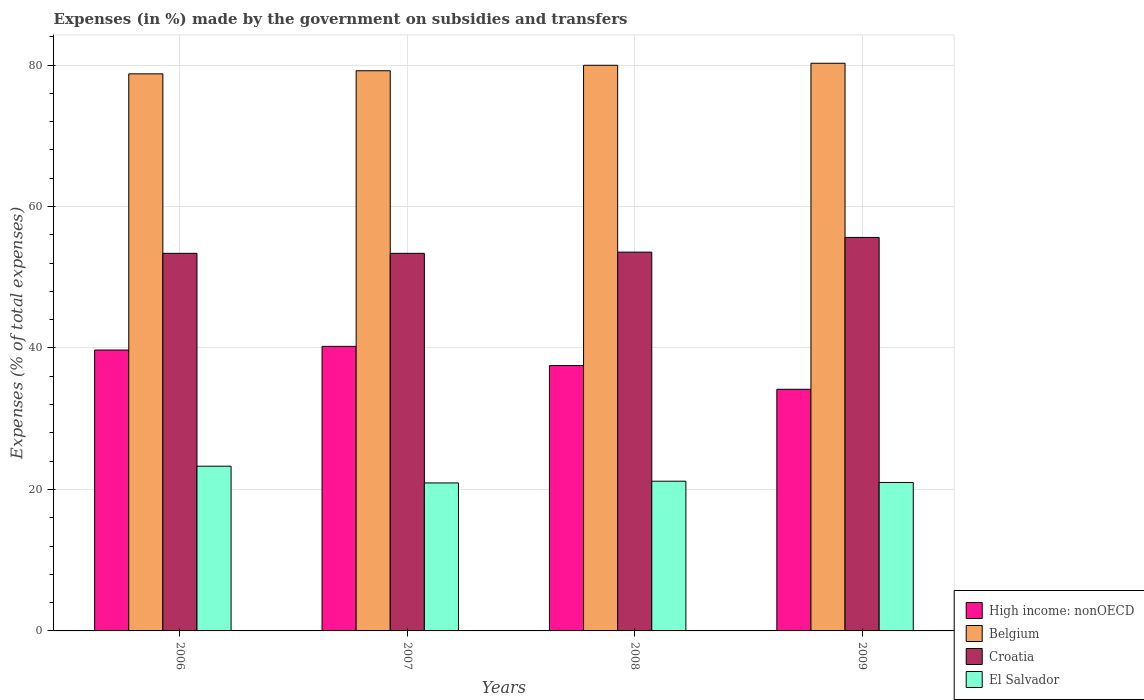How many different coloured bars are there?
Keep it short and to the point. 4. How many groups of bars are there?
Provide a short and direct response. 4. Are the number of bars per tick equal to the number of legend labels?
Offer a very short reply. Yes. How many bars are there on the 2nd tick from the left?
Your answer should be very brief. 4. What is the percentage of expenses made by the government on subsidies and transfers in El Salvador in 2008?
Your answer should be compact. 21.17. Across all years, what is the maximum percentage of expenses made by the government on subsidies and transfers in El Salvador?
Your answer should be very brief. 23.29. Across all years, what is the minimum percentage of expenses made by the government on subsidies and transfers in High income: nonOECD?
Ensure brevity in your answer.  34.16. In which year was the percentage of expenses made by the government on subsidies and transfers in High income: nonOECD maximum?
Provide a short and direct response. 2007. In which year was the percentage of expenses made by the government on subsidies and transfers in El Salvador minimum?
Make the answer very short. 2007. What is the total percentage of expenses made by the government on subsidies and transfers in Croatia in the graph?
Ensure brevity in your answer.  215.95. What is the difference between the percentage of expenses made by the government on subsidies and transfers in High income: nonOECD in 2006 and that in 2009?
Ensure brevity in your answer.  5.55. What is the difference between the percentage of expenses made by the government on subsidies and transfers in El Salvador in 2007 and the percentage of expenses made by the government on subsidies and transfers in Belgium in 2009?
Provide a short and direct response. -59.33. What is the average percentage of expenses made by the government on subsidies and transfers in Croatia per year?
Keep it short and to the point. 53.99. In the year 2008, what is the difference between the percentage of expenses made by the government on subsidies and transfers in High income: nonOECD and percentage of expenses made by the government on subsidies and transfers in El Salvador?
Your response must be concise. 16.35. In how many years, is the percentage of expenses made by the government on subsidies and transfers in Belgium greater than 24 %?
Keep it short and to the point. 4. What is the ratio of the percentage of expenses made by the government on subsidies and transfers in Croatia in 2006 to that in 2009?
Make the answer very short. 0.96. Is the difference between the percentage of expenses made by the government on subsidies and transfers in High income: nonOECD in 2006 and 2009 greater than the difference between the percentage of expenses made by the government on subsidies and transfers in El Salvador in 2006 and 2009?
Your answer should be very brief. Yes. What is the difference between the highest and the second highest percentage of expenses made by the government on subsidies and transfers in El Salvador?
Make the answer very short. 2.12. What is the difference between the highest and the lowest percentage of expenses made by the government on subsidies and transfers in Belgium?
Keep it short and to the point. 1.5. In how many years, is the percentage of expenses made by the government on subsidies and transfers in High income: nonOECD greater than the average percentage of expenses made by the government on subsidies and transfers in High income: nonOECD taken over all years?
Your answer should be very brief. 2. What does the 4th bar from the left in 2007 represents?
Give a very brief answer. El Salvador. What does the 3rd bar from the right in 2008 represents?
Provide a short and direct response. Belgium. How many bars are there?
Offer a terse response. 16. How many years are there in the graph?
Your answer should be very brief. 4. What is the difference between two consecutive major ticks on the Y-axis?
Your answer should be compact. 20. Are the values on the major ticks of Y-axis written in scientific E-notation?
Provide a short and direct response. No. Does the graph contain grids?
Your answer should be very brief. Yes. Where does the legend appear in the graph?
Offer a very short reply. Bottom right. What is the title of the graph?
Make the answer very short. Expenses (in %) made by the government on subsidies and transfers. Does "Iran" appear as one of the legend labels in the graph?
Give a very brief answer. No. What is the label or title of the Y-axis?
Your response must be concise. Expenses (% of total expenses). What is the Expenses (% of total expenses) of High income: nonOECD in 2006?
Provide a succinct answer. 39.71. What is the Expenses (% of total expenses) in Belgium in 2006?
Your answer should be very brief. 78.76. What is the Expenses (% of total expenses) in Croatia in 2006?
Offer a terse response. 53.38. What is the Expenses (% of total expenses) in El Salvador in 2006?
Ensure brevity in your answer.  23.29. What is the Expenses (% of total expenses) in High income: nonOECD in 2007?
Give a very brief answer. 40.23. What is the Expenses (% of total expenses) of Belgium in 2007?
Your answer should be very brief. 79.2. What is the Expenses (% of total expenses) in Croatia in 2007?
Offer a very short reply. 53.38. What is the Expenses (% of total expenses) in El Salvador in 2007?
Keep it short and to the point. 20.92. What is the Expenses (% of total expenses) of High income: nonOECD in 2008?
Keep it short and to the point. 37.52. What is the Expenses (% of total expenses) in Belgium in 2008?
Provide a succinct answer. 79.97. What is the Expenses (% of total expenses) of Croatia in 2008?
Make the answer very short. 53.55. What is the Expenses (% of total expenses) of El Salvador in 2008?
Offer a very short reply. 21.17. What is the Expenses (% of total expenses) of High income: nonOECD in 2009?
Give a very brief answer. 34.16. What is the Expenses (% of total expenses) of Belgium in 2009?
Ensure brevity in your answer.  80.26. What is the Expenses (% of total expenses) of Croatia in 2009?
Your response must be concise. 55.63. What is the Expenses (% of total expenses) in El Salvador in 2009?
Your answer should be very brief. 20.99. Across all years, what is the maximum Expenses (% of total expenses) of High income: nonOECD?
Give a very brief answer. 40.23. Across all years, what is the maximum Expenses (% of total expenses) of Belgium?
Give a very brief answer. 80.26. Across all years, what is the maximum Expenses (% of total expenses) in Croatia?
Make the answer very short. 55.63. Across all years, what is the maximum Expenses (% of total expenses) of El Salvador?
Your answer should be very brief. 23.29. Across all years, what is the minimum Expenses (% of total expenses) in High income: nonOECD?
Your answer should be very brief. 34.16. Across all years, what is the minimum Expenses (% of total expenses) of Belgium?
Give a very brief answer. 78.76. Across all years, what is the minimum Expenses (% of total expenses) in Croatia?
Offer a terse response. 53.38. Across all years, what is the minimum Expenses (% of total expenses) of El Salvador?
Give a very brief answer. 20.92. What is the total Expenses (% of total expenses) in High income: nonOECD in the graph?
Offer a very short reply. 151.62. What is the total Expenses (% of total expenses) of Belgium in the graph?
Offer a terse response. 318.18. What is the total Expenses (% of total expenses) of Croatia in the graph?
Offer a very short reply. 215.95. What is the total Expenses (% of total expenses) of El Salvador in the graph?
Make the answer very short. 86.37. What is the difference between the Expenses (% of total expenses) of High income: nonOECD in 2006 and that in 2007?
Keep it short and to the point. -0.52. What is the difference between the Expenses (% of total expenses) of Belgium in 2006 and that in 2007?
Offer a terse response. -0.44. What is the difference between the Expenses (% of total expenses) of Croatia in 2006 and that in 2007?
Give a very brief answer. 0. What is the difference between the Expenses (% of total expenses) of El Salvador in 2006 and that in 2007?
Your response must be concise. 2.37. What is the difference between the Expenses (% of total expenses) in High income: nonOECD in 2006 and that in 2008?
Ensure brevity in your answer.  2.19. What is the difference between the Expenses (% of total expenses) in Belgium in 2006 and that in 2008?
Ensure brevity in your answer.  -1.21. What is the difference between the Expenses (% of total expenses) in Croatia in 2006 and that in 2008?
Offer a terse response. -0.17. What is the difference between the Expenses (% of total expenses) in El Salvador in 2006 and that in 2008?
Make the answer very short. 2.12. What is the difference between the Expenses (% of total expenses) in High income: nonOECD in 2006 and that in 2009?
Ensure brevity in your answer.  5.55. What is the difference between the Expenses (% of total expenses) in Belgium in 2006 and that in 2009?
Your answer should be very brief. -1.5. What is the difference between the Expenses (% of total expenses) of Croatia in 2006 and that in 2009?
Your answer should be very brief. -2.25. What is the difference between the Expenses (% of total expenses) in El Salvador in 2006 and that in 2009?
Make the answer very short. 2.3. What is the difference between the Expenses (% of total expenses) in High income: nonOECD in 2007 and that in 2008?
Your answer should be very brief. 2.71. What is the difference between the Expenses (% of total expenses) of Belgium in 2007 and that in 2008?
Give a very brief answer. -0.77. What is the difference between the Expenses (% of total expenses) in Croatia in 2007 and that in 2008?
Provide a succinct answer. -0.17. What is the difference between the Expenses (% of total expenses) in El Salvador in 2007 and that in 2008?
Offer a very short reply. -0.24. What is the difference between the Expenses (% of total expenses) in High income: nonOECD in 2007 and that in 2009?
Your answer should be very brief. 6.07. What is the difference between the Expenses (% of total expenses) in Belgium in 2007 and that in 2009?
Offer a very short reply. -1.06. What is the difference between the Expenses (% of total expenses) in Croatia in 2007 and that in 2009?
Offer a terse response. -2.25. What is the difference between the Expenses (% of total expenses) in El Salvador in 2007 and that in 2009?
Make the answer very short. -0.06. What is the difference between the Expenses (% of total expenses) of High income: nonOECD in 2008 and that in 2009?
Offer a very short reply. 3.36. What is the difference between the Expenses (% of total expenses) in Belgium in 2008 and that in 2009?
Provide a succinct answer. -0.29. What is the difference between the Expenses (% of total expenses) in Croatia in 2008 and that in 2009?
Give a very brief answer. -2.08. What is the difference between the Expenses (% of total expenses) in El Salvador in 2008 and that in 2009?
Give a very brief answer. 0.18. What is the difference between the Expenses (% of total expenses) of High income: nonOECD in 2006 and the Expenses (% of total expenses) of Belgium in 2007?
Keep it short and to the point. -39.49. What is the difference between the Expenses (% of total expenses) in High income: nonOECD in 2006 and the Expenses (% of total expenses) in Croatia in 2007?
Give a very brief answer. -13.67. What is the difference between the Expenses (% of total expenses) of High income: nonOECD in 2006 and the Expenses (% of total expenses) of El Salvador in 2007?
Your response must be concise. 18.79. What is the difference between the Expenses (% of total expenses) of Belgium in 2006 and the Expenses (% of total expenses) of Croatia in 2007?
Provide a succinct answer. 25.38. What is the difference between the Expenses (% of total expenses) of Belgium in 2006 and the Expenses (% of total expenses) of El Salvador in 2007?
Your answer should be very brief. 57.84. What is the difference between the Expenses (% of total expenses) in Croatia in 2006 and the Expenses (% of total expenses) in El Salvador in 2007?
Give a very brief answer. 32.46. What is the difference between the Expenses (% of total expenses) of High income: nonOECD in 2006 and the Expenses (% of total expenses) of Belgium in 2008?
Offer a terse response. -40.26. What is the difference between the Expenses (% of total expenses) of High income: nonOECD in 2006 and the Expenses (% of total expenses) of Croatia in 2008?
Provide a short and direct response. -13.84. What is the difference between the Expenses (% of total expenses) of High income: nonOECD in 2006 and the Expenses (% of total expenses) of El Salvador in 2008?
Offer a very short reply. 18.54. What is the difference between the Expenses (% of total expenses) in Belgium in 2006 and the Expenses (% of total expenses) in Croatia in 2008?
Offer a very short reply. 25.21. What is the difference between the Expenses (% of total expenses) in Belgium in 2006 and the Expenses (% of total expenses) in El Salvador in 2008?
Provide a short and direct response. 57.59. What is the difference between the Expenses (% of total expenses) of Croatia in 2006 and the Expenses (% of total expenses) of El Salvador in 2008?
Your answer should be compact. 32.22. What is the difference between the Expenses (% of total expenses) of High income: nonOECD in 2006 and the Expenses (% of total expenses) of Belgium in 2009?
Your response must be concise. -40.55. What is the difference between the Expenses (% of total expenses) in High income: nonOECD in 2006 and the Expenses (% of total expenses) in Croatia in 2009?
Ensure brevity in your answer.  -15.92. What is the difference between the Expenses (% of total expenses) in High income: nonOECD in 2006 and the Expenses (% of total expenses) in El Salvador in 2009?
Make the answer very short. 18.72. What is the difference between the Expenses (% of total expenses) in Belgium in 2006 and the Expenses (% of total expenses) in Croatia in 2009?
Keep it short and to the point. 23.13. What is the difference between the Expenses (% of total expenses) in Belgium in 2006 and the Expenses (% of total expenses) in El Salvador in 2009?
Your answer should be compact. 57.77. What is the difference between the Expenses (% of total expenses) in Croatia in 2006 and the Expenses (% of total expenses) in El Salvador in 2009?
Offer a terse response. 32.4. What is the difference between the Expenses (% of total expenses) of High income: nonOECD in 2007 and the Expenses (% of total expenses) of Belgium in 2008?
Offer a very short reply. -39.74. What is the difference between the Expenses (% of total expenses) in High income: nonOECD in 2007 and the Expenses (% of total expenses) in Croatia in 2008?
Offer a very short reply. -13.32. What is the difference between the Expenses (% of total expenses) in High income: nonOECD in 2007 and the Expenses (% of total expenses) in El Salvador in 2008?
Your answer should be compact. 19.06. What is the difference between the Expenses (% of total expenses) of Belgium in 2007 and the Expenses (% of total expenses) of Croatia in 2008?
Your response must be concise. 25.64. What is the difference between the Expenses (% of total expenses) of Belgium in 2007 and the Expenses (% of total expenses) of El Salvador in 2008?
Your response must be concise. 58.03. What is the difference between the Expenses (% of total expenses) in Croatia in 2007 and the Expenses (% of total expenses) in El Salvador in 2008?
Ensure brevity in your answer.  32.22. What is the difference between the Expenses (% of total expenses) in High income: nonOECD in 2007 and the Expenses (% of total expenses) in Belgium in 2009?
Your answer should be compact. -40.03. What is the difference between the Expenses (% of total expenses) of High income: nonOECD in 2007 and the Expenses (% of total expenses) of Croatia in 2009?
Provide a succinct answer. -15.4. What is the difference between the Expenses (% of total expenses) of High income: nonOECD in 2007 and the Expenses (% of total expenses) of El Salvador in 2009?
Your response must be concise. 19.24. What is the difference between the Expenses (% of total expenses) of Belgium in 2007 and the Expenses (% of total expenses) of Croatia in 2009?
Ensure brevity in your answer.  23.56. What is the difference between the Expenses (% of total expenses) in Belgium in 2007 and the Expenses (% of total expenses) in El Salvador in 2009?
Offer a terse response. 58.21. What is the difference between the Expenses (% of total expenses) of Croatia in 2007 and the Expenses (% of total expenses) of El Salvador in 2009?
Ensure brevity in your answer.  32.4. What is the difference between the Expenses (% of total expenses) in High income: nonOECD in 2008 and the Expenses (% of total expenses) in Belgium in 2009?
Provide a short and direct response. -42.74. What is the difference between the Expenses (% of total expenses) of High income: nonOECD in 2008 and the Expenses (% of total expenses) of Croatia in 2009?
Your answer should be very brief. -18.11. What is the difference between the Expenses (% of total expenses) in High income: nonOECD in 2008 and the Expenses (% of total expenses) in El Salvador in 2009?
Your answer should be very brief. 16.53. What is the difference between the Expenses (% of total expenses) of Belgium in 2008 and the Expenses (% of total expenses) of Croatia in 2009?
Your answer should be very brief. 24.34. What is the difference between the Expenses (% of total expenses) of Belgium in 2008 and the Expenses (% of total expenses) of El Salvador in 2009?
Offer a terse response. 58.98. What is the difference between the Expenses (% of total expenses) in Croatia in 2008 and the Expenses (% of total expenses) in El Salvador in 2009?
Your answer should be very brief. 32.57. What is the average Expenses (% of total expenses) of High income: nonOECD per year?
Keep it short and to the point. 37.9. What is the average Expenses (% of total expenses) in Belgium per year?
Your answer should be very brief. 79.55. What is the average Expenses (% of total expenses) of Croatia per year?
Ensure brevity in your answer.  53.99. What is the average Expenses (% of total expenses) of El Salvador per year?
Give a very brief answer. 21.59. In the year 2006, what is the difference between the Expenses (% of total expenses) in High income: nonOECD and Expenses (% of total expenses) in Belgium?
Your response must be concise. -39.05. In the year 2006, what is the difference between the Expenses (% of total expenses) of High income: nonOECD and Expenses (% of total expenses) of Croatia?
Provide a short and direct response. -13.67. In the year 2006, what is the difference between the Expenses (% of total expenses) of High income: nonOECD and Expenses (% of total expenses) of El Salvador?
Offer a terse response. 16.42. In the year 2006, what is the difference between the Expenses (% of total expenses) in Belgium and Expenses (% of total expenses) in Croatia?
Your answer should be compact. 25.38. In the year 2006, what is the difference between the Expenses (% of total expenses) in Belgium and Expenses (% of total expenses) in El Salvador?
Your answer should be very brief. 55.47. In the year 2006, what is the difference between the Expenses (% of total expenses) in Croatia and Expenses (% of total expenses) in El Salvador?
Offer a terse response. 30.09. In the year 2007, what is the difference between the Expenses (% of total expenses) of High income: nonOECD and Expenses (% of total expenses) of Belgium?
Your answer should be very brief. -38.97. In the year 2007, what is the difference between the Expenses (% of total expenses) of High income: nonOECD and Expenses (% of total expenses) of Croatia?
Keep it short and to the point. -13.15. In the year 2007, what is the difference between the Expenses (% of total expenses) of High income: nonOECD and Expenses (% of total expenses) of El Salvador?
Provide a succinct answer. 19.31. In the year 2007, what is the difference between the Expenses (% of total expenses) of Belgium and Expenses (% of total expenses) of Croatia?
Keep it short and to the point. 25.81. In the year 2007, what is the difference between the Expenses (% of total expenses) in Belgium and Expenses (% of total expenses) in El Salvador?
Keep it short and to the point. 58.27. In the year 2007, what is the difference between the Expenses (% of total expenses) in Croatia and Expenses (% of total expenses) in El Salvador?
Make the answer very short. 32.46. In the year 2008, what is the difference between the Expenses (% of total expenses) in High income: nonOECD and Expenses (% of total expenses) in Belgium?
Provide a succinct answer. -42.45. In the year 2008, what is the difference between the Expenses (% of total expenses) of High income: nonOECD and Expenses (% of total expenses) of Croatia?
Offer a terse response. -16.04. In the year 2008, what is the difference between the Expenses (% of total expenses) in High income: nonOECD and Expenses (% of total expenses) in El Salvador?
Provide a short and direct response. 16.35. In the year 2008, what is the difference between the Expenses (% of total expenses) of Belgium and Expenses (% of total expenses) of Croatia?
Your answer should be very brief. 26.42. In the year 2008, what is the difference between the Expenses (% of total expenses) of Belgium and Expenses (% of total expenses) of El Salvador?
Give a very brief answer. 58.8. In the year 2008, what is the difference between the Expenses (% of total expenses) in Croatia and Expenses (% of total expenses) in El Salvador?
Offer a terse response. 32.39. In the year 2009, what is the difference between the Expenses (% of total expenses) in High income: nonOECD and Expenses (% of total expenses) in Belgium?
Provide a succinct answer. -46.09. In the year 2009, what is the difference between the Expenses (% of total expenses) in High income: nonOECD and Expenses (% of total expenses) in Croatia?
Ensure brevity in your answer.  -21.47. In the year 2009, what is the difference between the Expenses (% of total expenses) of High income: nonOECD and Expenses (% of total expenses) of El Salvador?
Keep it short and to the point. 13.17. In the year 2009, what is the difference between the Expenses (% of total expenses) of Belgium and Expenses (% of total expenses) of Croatia?
Give a very brief answer. 24.62. In the year 2009, what is the difference between the Expenses (% of total expenses) of Belgium and Expenses (% of total expenses) of El Salvador?
Your response must be concise. 59.27. In the year 2009, what is the difference between the Expenses (% of total expenses) in Croatia and Expenses (% of total expenses) in El Salvador?
Provide a succinct answer. 34.65. What is the ratio of the Expenses (% of total expenses) of High income: nonOECD in 2006 to that in 2007?
Provide a succinct answer. 0.99. What is the ratio of the Expenses (% of total expenses) of El Salvador in 2006 to that in 2007?
Give a very brief answer. 1.11. What is the ratio of the Expenses (% of total expenses) in High income: nonOECD in 2006 to that in 2008?
Provide a succinct answer. 1.06. What is the ratio of the Expenses (% of total expenses) in Belgium in 2006 to that in 2008?
Your response must be concise. 0.98. What is the ratio of the Expenses (% of total expenses) of El Salvador in 2006 to that in 2008?
Keep it short and to the point. 1.1. What is the ratio of the Expenses (% of total expenses) of High income: nonOECD in 2006 to that in 2009?
Give a very brief answer. 1.16. What is the ratio of the Expenses (% of total expenses) of Belgium in 2006 to that in 2009?
Your answer should be very brief. 0.98. What is the ratio of the Expenses (% of total expenses) in Croatia in 2006 to that in 2009?
Make the answer very short. 0.96. What is the ratio of the Expenses (% of total expenses) in El Salvador in 2006 to that in 2009?
Keep it short and to the point. 1.11. What is the ratio of the Expenses (% of total expenses) in High income: nonOECD in 2007 to that in 2008?
Give a very brief answer. 1.07. What is the ratio of the Expenses (% of total expenses) of Belgium in 2007 to that in 2008?
Your answer should be compact. 0.99. What is the ratio of the Expenses (% of total expenses) of Croatia in 2007 to that in 2008?
Your answer should be compact. 1. What is the ratio of the Expenses (% of total expenses) in El Salvador in 2007 to that in 2008?
Make the answer very short. 0.99. What is the ratio of the Expenses (% of total expenses) in High income: nonOECD in 2007 to that in 2009?
Give a very brief answer. 1.18. What is the ratio of the Expenses (% of total expenses) of Belgium in 2007 to that in 2009?
Your answer should be very brief. 0.99. What is the ratio of the Expenses (% of total expenses) of Croatia in 2007 to that in 2009?
Give a very brief answer. 0.96. What is the ratio of the Expenses (% of total expenses) in El Salvador in 2007 to that in 2009?
Give a very brief answer. 1. What is the ratio of the Expenses (% of total expenses) in High income: nonOECD in 2008 to that in 2009?
Your answer should be very brief. 1.1. What is the ratio of the Expenses (% of total expenses) in Croatia in 2008 to that in 2009?
Provide a succinct answer. 0.96. What is the ratio of the Expenses (% of total expenses) in El Salvador in 2008 to that in 2009?
Ensure brevity in your answer.  1.01. What is the difference between the highest and the second highest Expenses (% of total expenses) of High income: nonOECD?
Provide a short and direct response. 0.52. What is the difference between the highest and the second highest Expenses (% of total expenses) of Belgium?
Offer a very short reply. 0.29. What is the difference between the highest and the second highest Expenses (% of total expenses) of Croatia?
Your answer should be compact. 2.08. What is the difference between the highest and the second highest Expenses (% of total expenses) of El Salvador?
Your response must be concise. 2.12. What is the difference between the highest and the lowest Expenses (% of total expenses) of High income: nonOECD?
Your response must be concise. 6.07. What is the difference between the highest and the lowest Expenses (% of total expenses) in Belgium?
Your response must be concise. 1.5. What is the difference between the highest and the lowest Expenses (% of total expenses) in Croatia?
Keep it short and to the point. 2.25. What is the difference between the highest and the lowest Expenses (% of total expenses) in El Salvador?
Offer a very short reply. 2.37. 